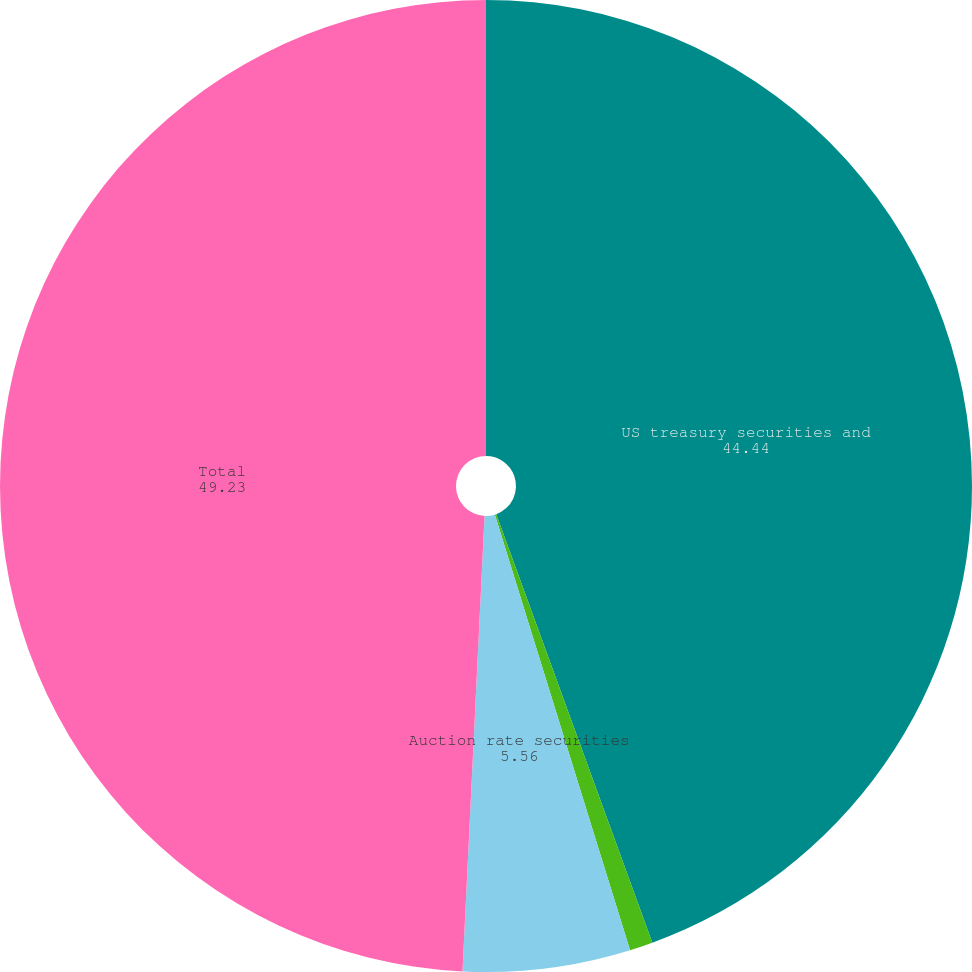Convert chart to OTSL. <chart><loc_0><loc_0><loc_500><loc_500><pie_chart><fcel>US treasury securities and<fcel>Obligations of states and<fcel>Auction rate securities<fcel>Total<nl><fcel>44.44%<fcel>0.77%<fcel>5.56%<fcel>49.23%<nl></chart> 